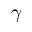Convert formula to latex. <formula><loc_0><loc_0><loc_500><loc_500>\gamma</formula> 